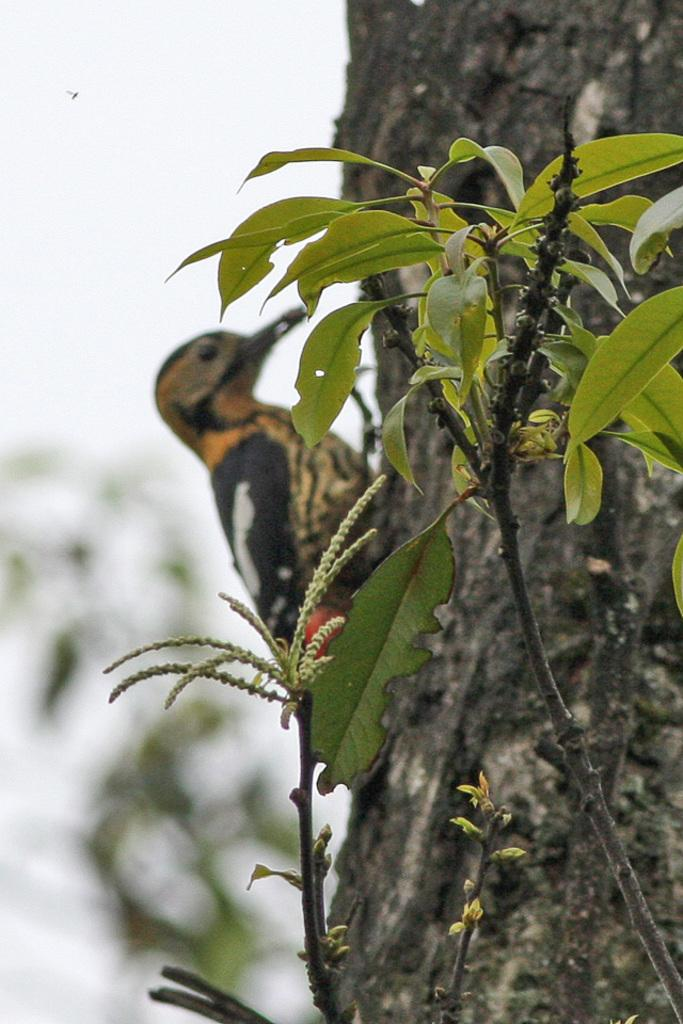What type of animal is in the image? There is a bird in the image. What colors can be seen on the bird? The bird is black and brown in color. Where is the bird located in the image? The bird is on a tree. What other living organism is present in the image? There is a plant in the image. What color is the plant? The plant is green in color. What can be seen in the background of the image? The sky is visible in the background of the image. What color is the sky? The sky is white in color. How many rabbits are participating in the feast in the image? There are no rabbits or feast present in the image. What type of prose is being recited by the bird in the image? There is no prose or recitation in the image; it simply shows a bird on a tree. 